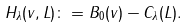<formula> <loc_0><loc_0><loc_500><loc_500>H _ { \lambda } ( v , L ) \colon = B _ { 0 } ( v ) - C _ { \lambda } ( L ) .</formula> 